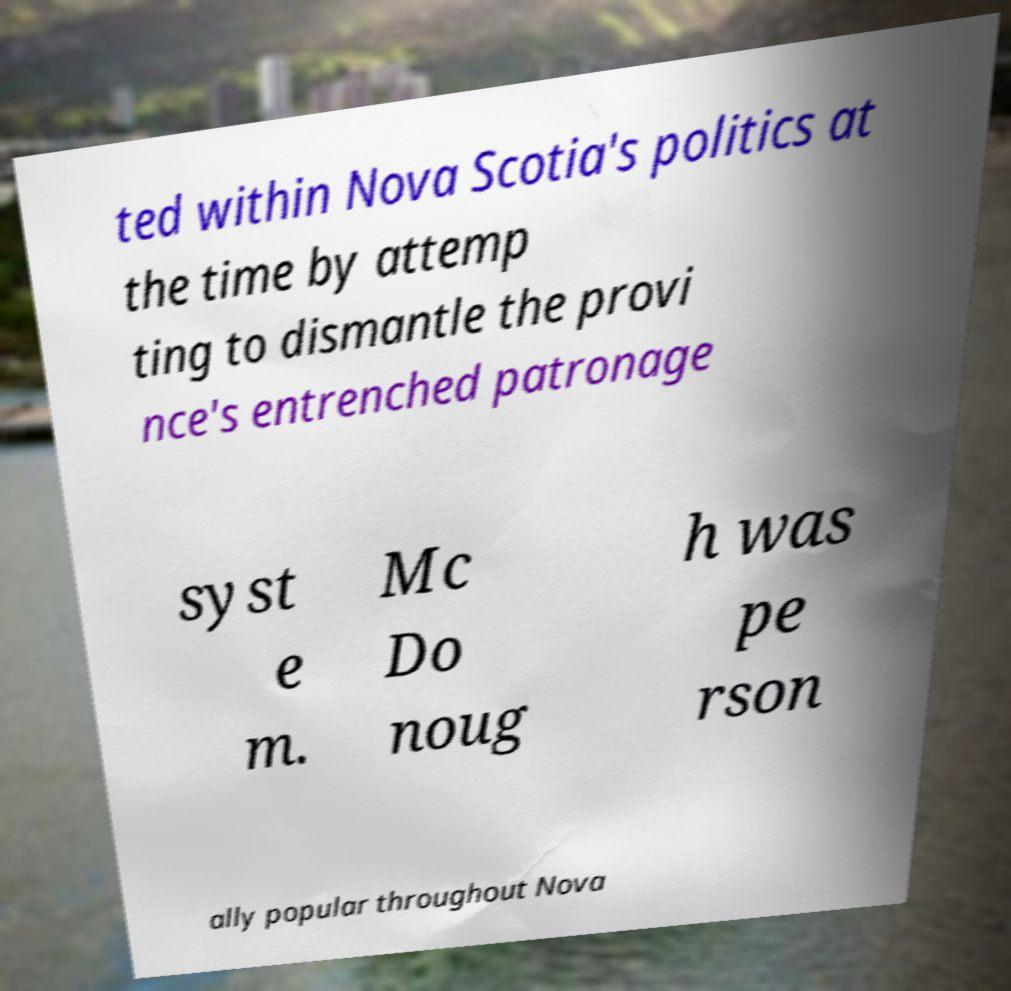Can you read and provide the text displayed in the image?This photo seems to have some interesting text. Can you extract and type it out for me? ted within Nova Scotia's politics at the time by attemp ting to dismantle the provi nce's entrenched patronage syst e m. Mc Do noug h was pe rson ally popular throughout Nova 